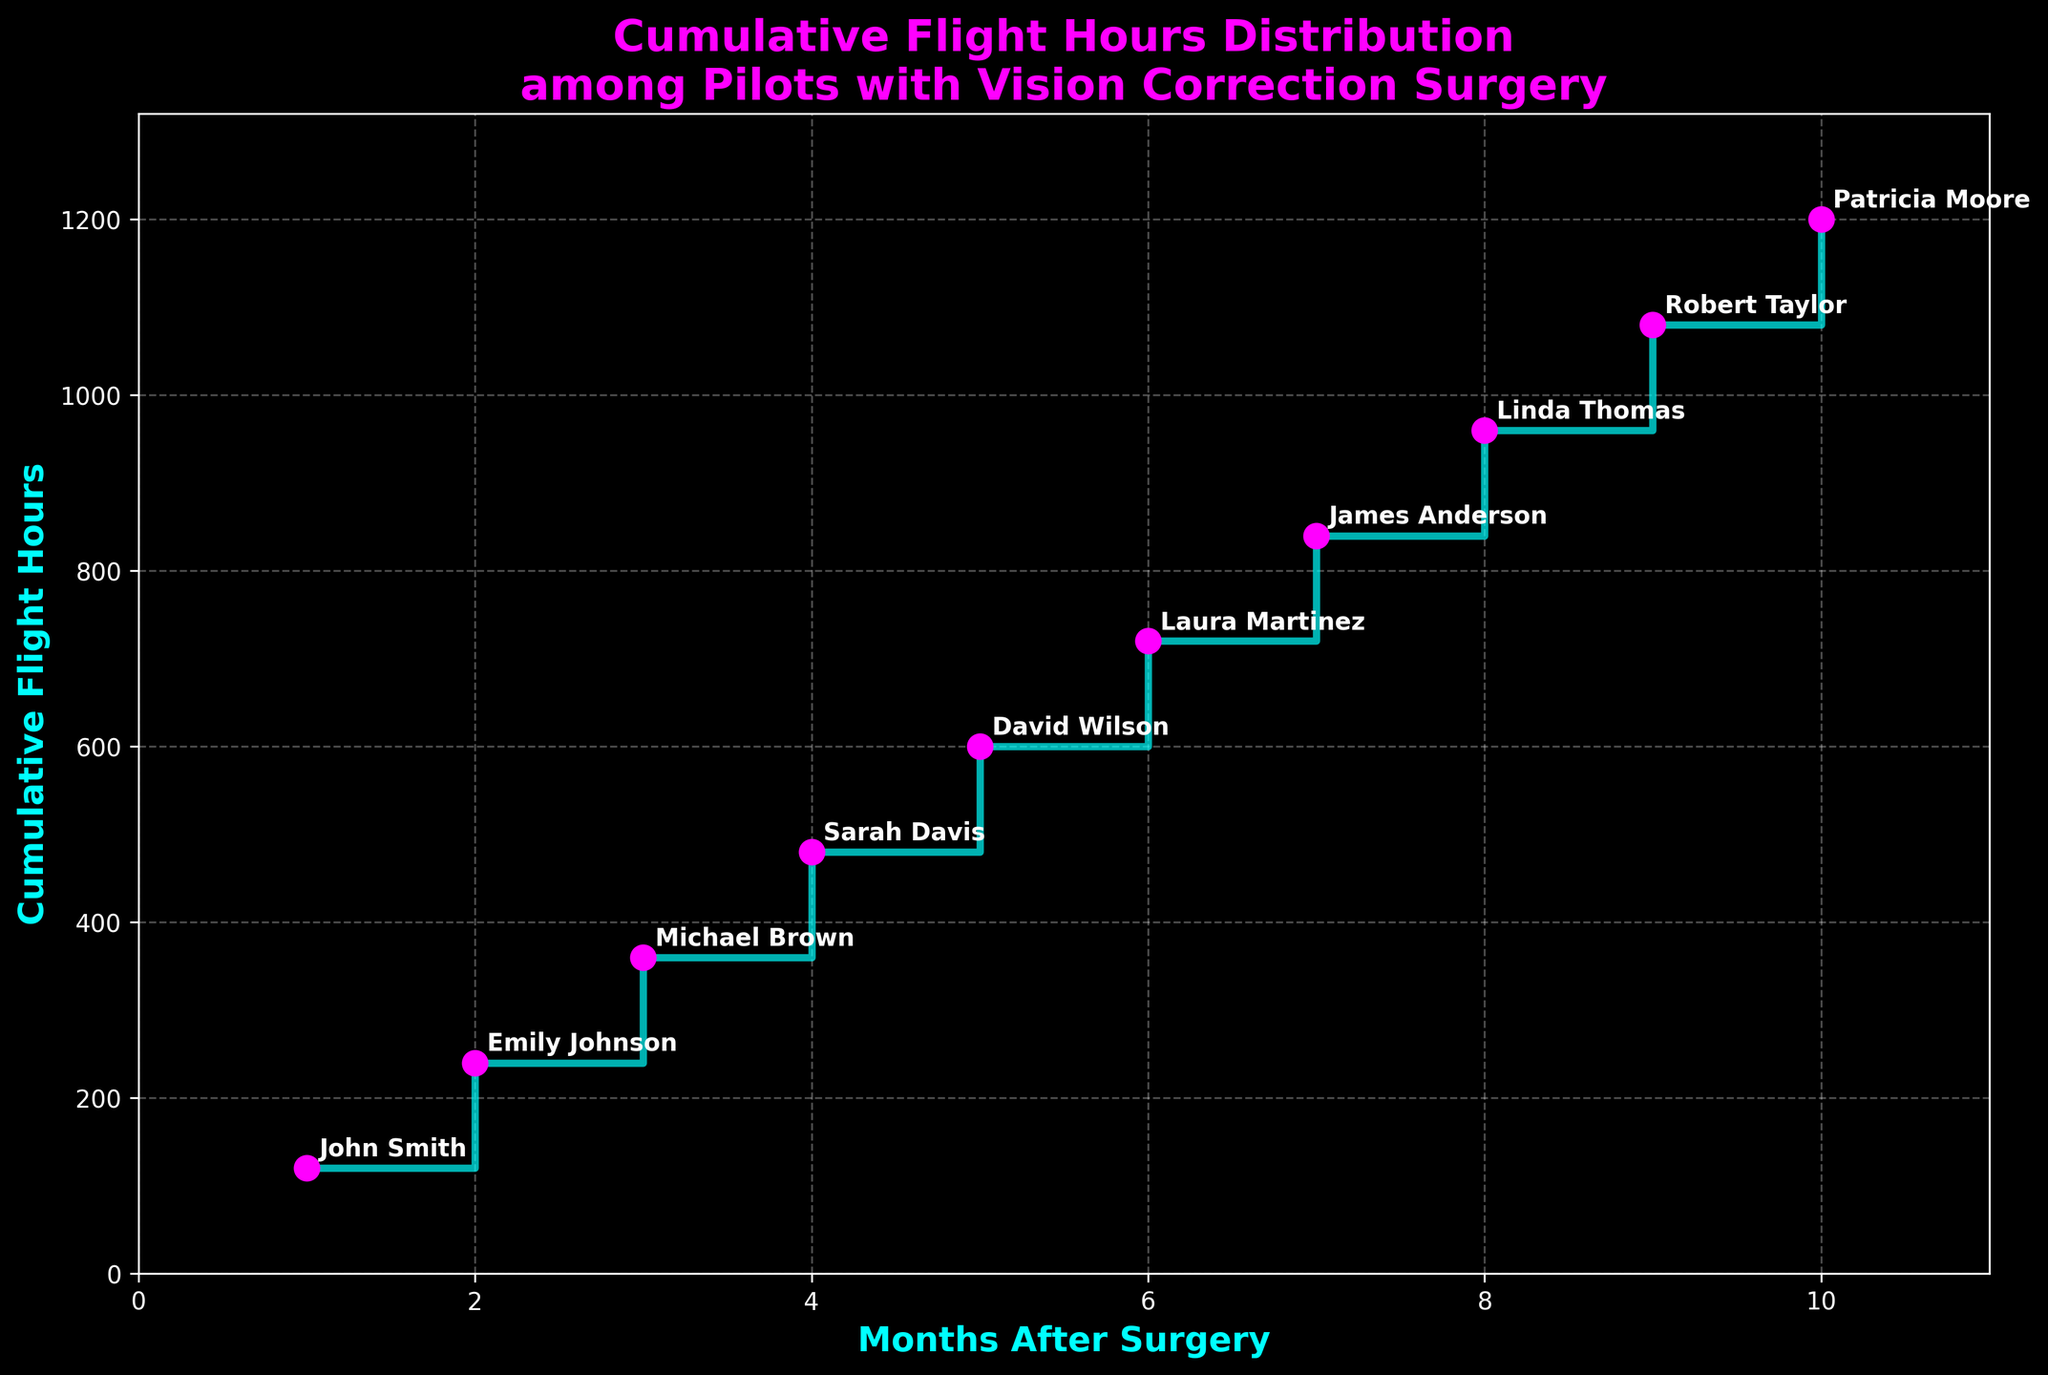What is the title of the plot? The title of the plot is written at the top of the figure, which summarizes what the figure is about.
Answer: Cumulative Flight Hours Distribution among Pilots with Vision Correction Surgery How many pilots are represented in the plot? Each data point represents one pilot, identifiable by the annotated names. Counting these annotations will give the total number of pilots.
Answer: 10 Which pilot has the highest cumulative flight hours? By looking at the rightmost point on the vertical axis and identifying the associated name, you can see the pilot with the highest cumulative flight hours.
Answer: Patricia Moore What is the cumulative flight hours difference between Michael Brown and Linda Thomas? First, find the cumulative flight hours for Michael Brown and Linda Thomas from the y-values; then subtract Michael's value from Linda's value (960 - 360).
Answer: 600 How much did Sarah Davis' cumulative flight hours increase from John Smith? Find the cumulative flight hours for both Sarah Davis and John Smith; subtract John’s hours from Sarah’s hours (480 - 120).
Answer: 360 How many months after surgery did David Wilson reach 600 cumulative flight hours? Refer to the x-value where David Wilson’s y-value is 600.
Answer: 5 months Which pilot reached 720 cumulative flight hours? Look for the y-value of 720 and find the associated pilot's name annotation at that point.
Answer: Laura Martinez What is the average cumulative flight hours among all pilots? Sum all the cumulative flight hours and divide by the number of pilots ((120 + 240 + 360 + 480 + 600 + 720 + 840 + 960 + 1080 + 1200) / 10).
Answer: 660 Whose cumulative flight hours increased to 840 at 7 months post-surgery? Look for the x-value of 7 months and find the y-value of 840 to identify the associated pilot's name annotation.
Answer: James Anderson Do any pilots share the same cumulative flight hours increment within the plotted months? By scanning the plot, you can observe the increments between successive pilots. This involves examining each step on the plot and confirming any matching values.
Answer: No 